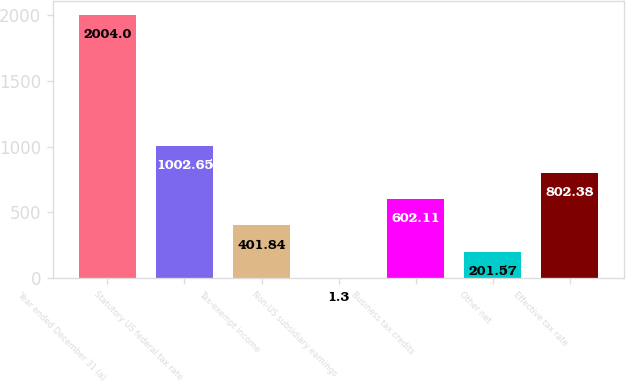<chart> <loc_0><loc_0><loc_500><loc_500><bar_chart><fcel>Year ended December 31 (a)<fcel>Statutory US federal tax rate<fcel>Tax-exempt income<fcel>Non-US subsidiary earnings<fcel>Business tax credits<fcel>Other net<fcel>Effective tax rate<nl><fcel>2004<fcel>1002.65<fcel>401.84<fcel>1.3<fcel>602.11<fcel>201.57<fcel>802.38<nl></chart> 